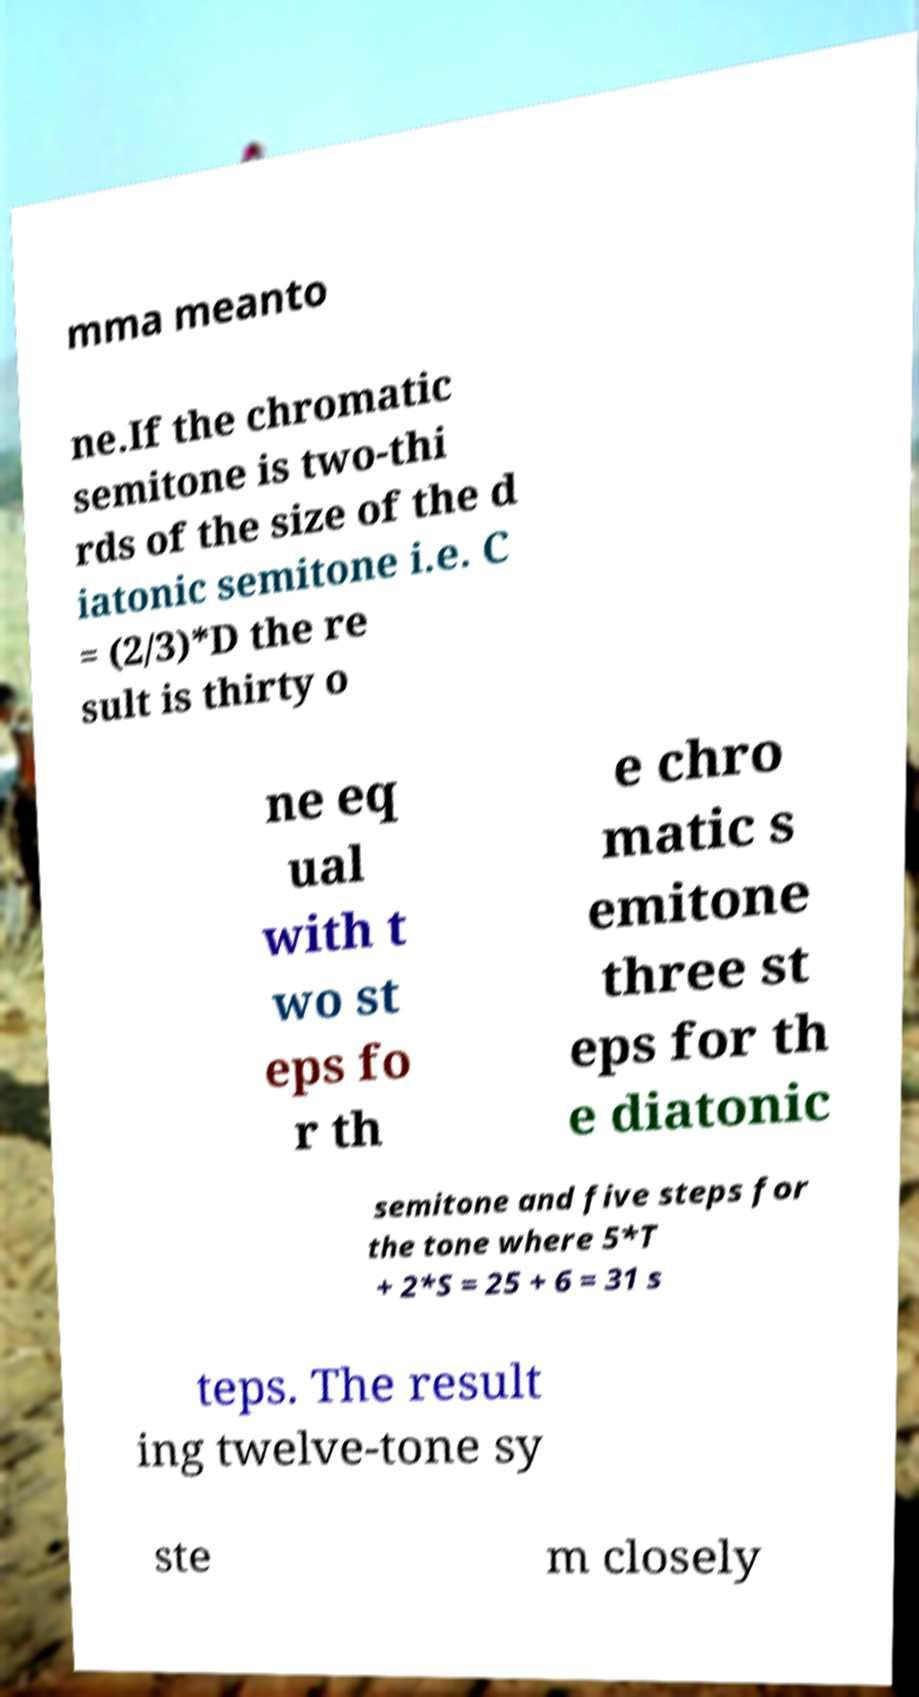For documentation purposes, I need the text within this image transcribed. Could you provide that? mma meanto ne.If the chromatic semitone is two-thi rds of the size of the d iatonic semitone i.e. C = (2/3)*D the re sult is thirty o ne eq ual with t wo st eps fo r th e chro matic s emitone three st eps for th e diatonic semitone and five steps for the tone where 5*T + 2*S = 25 + 6 = 31 s teps. The result ing twelve-tone sy ste m closely 